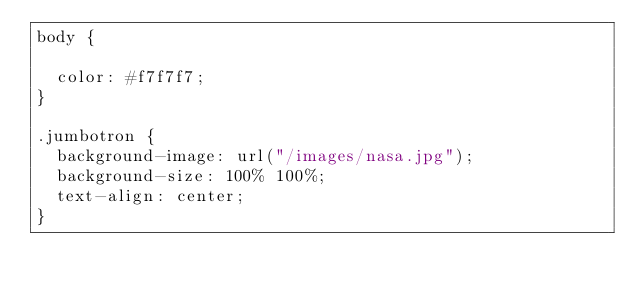<code> <loc_0><loc_0><loc_500><loc_500><_CSS_>body {

  color: #f7f7f7;
}

.jumbotron {
  background-image: url("/images/nasa.jpg");
  background-size: 100% 100%;
  text-align: center;
}</code> 